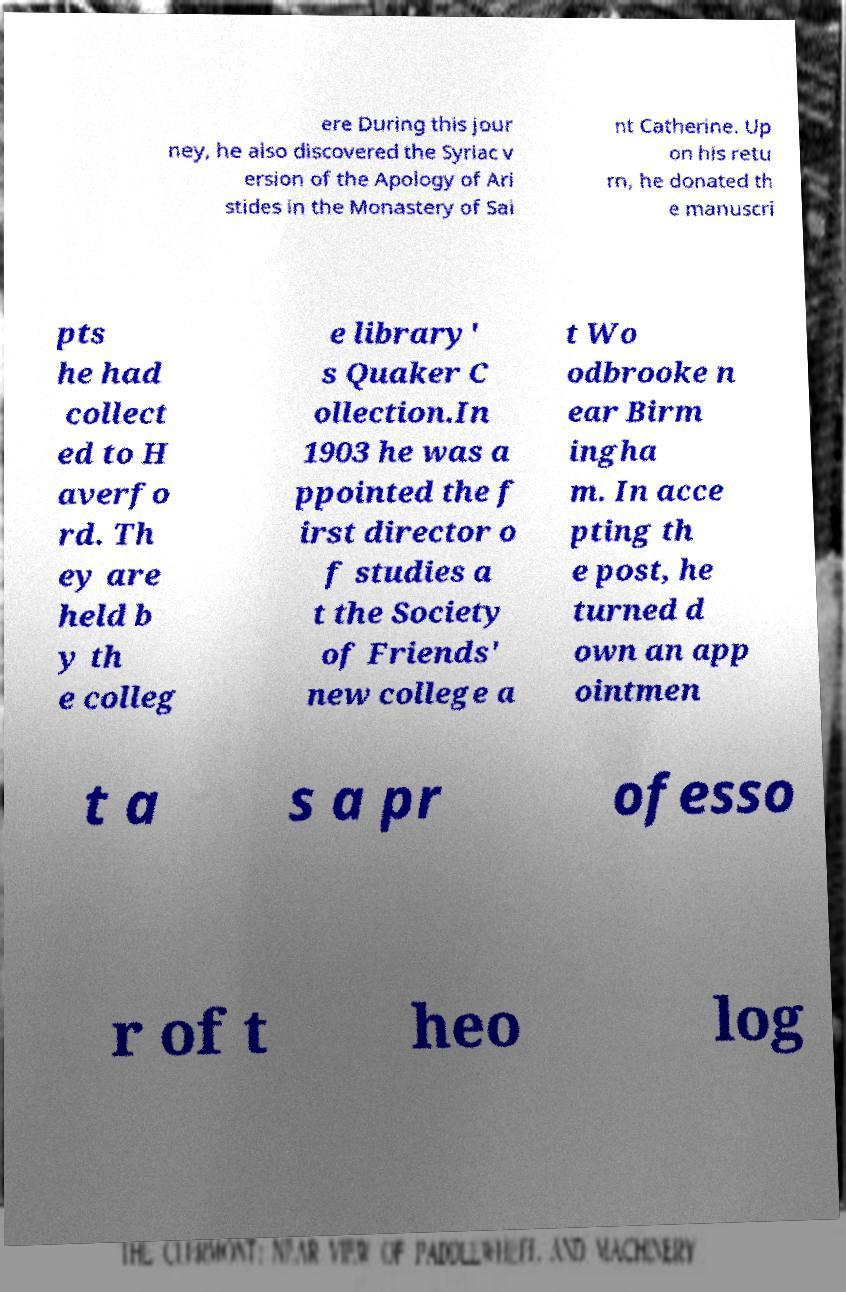What messages or text are displayed in this image? I need them in a readable, typed format. ere During this jour ney, he also discovered the Syriac v ersion of the Apology of Ari stides in the Monastery of Sai nt Catherine. Up on his retu rn, he donated th e manuscri pts he had collect ed to H averfo rd. Th ey are held b y th e colleg e library' s Quaker C ollection.In 1903 he was a ppointed the f irst director o f studies a t the Society of Friends' new college a t Wo odbrooke n ear Birm ingha m. In acce pting th e post, he turned d own an app ointmen t a s a pr ofesso r of t heo log 